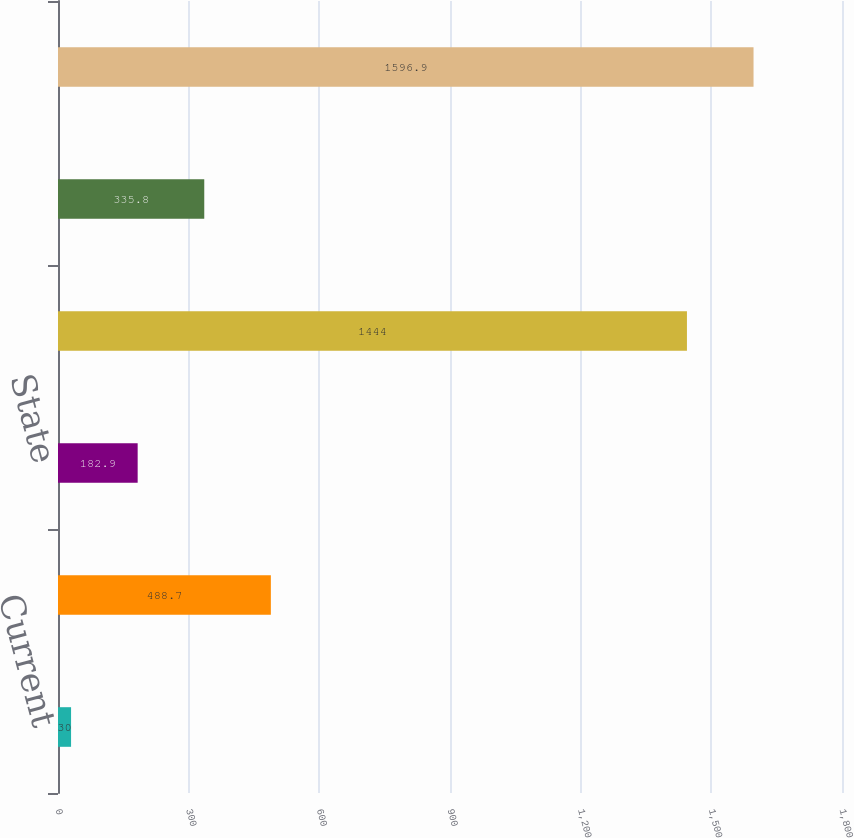<chart> <loc_0><loc_0><loc_500><loc_500><bar_chart><fcel>Current<fcel>Deferred<fcel>State<fcel>Total<fcel>Unnamed: 4<fcel>Total provision for income<nl><fcel>30<fcel>488.7<fcel>182.9<fcel>1444<fcel>335.8<fcel>1596.9<nl></chart> 